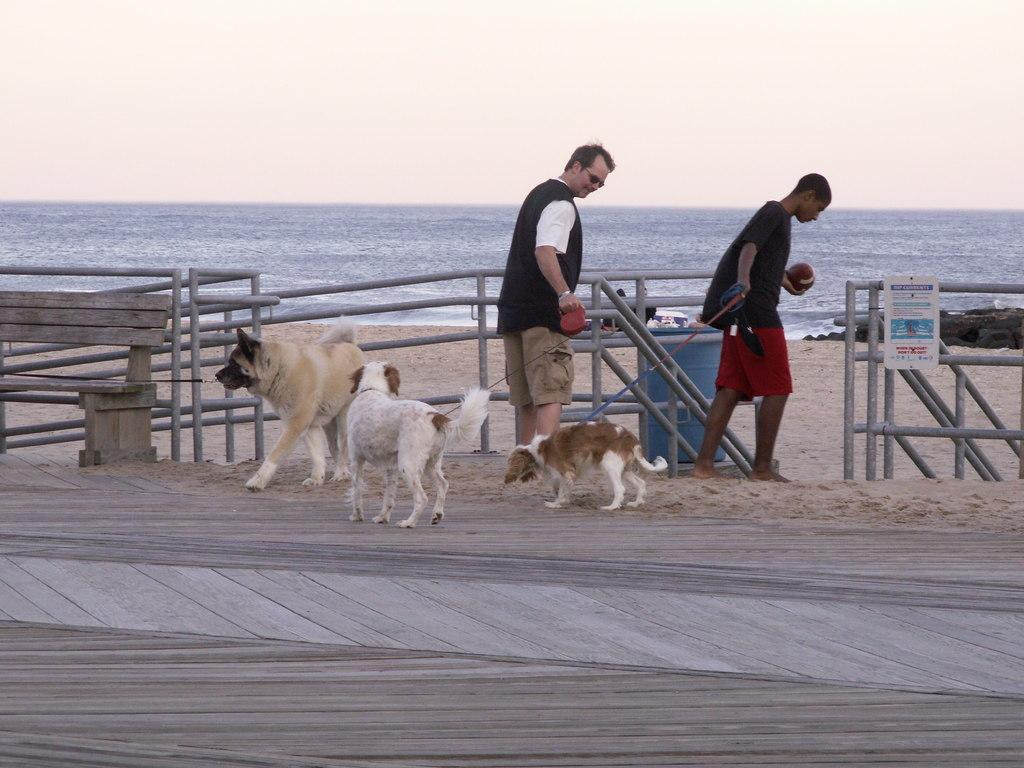How many men are in the image? There are 2 men in the image. How many dogs are in the image? There are 3 dogs in the image. Where are the men and dogs located in the image? The men and dogs are on a path in the image. What can be seen in the background of the image? There is a fence, sand, water, and the sky visible in the background of the image. What type of smile can be seen on the faces of the men in the image? There is no information about the men's facial expressions in the image, so we cannot determine if they are smiling or not. 